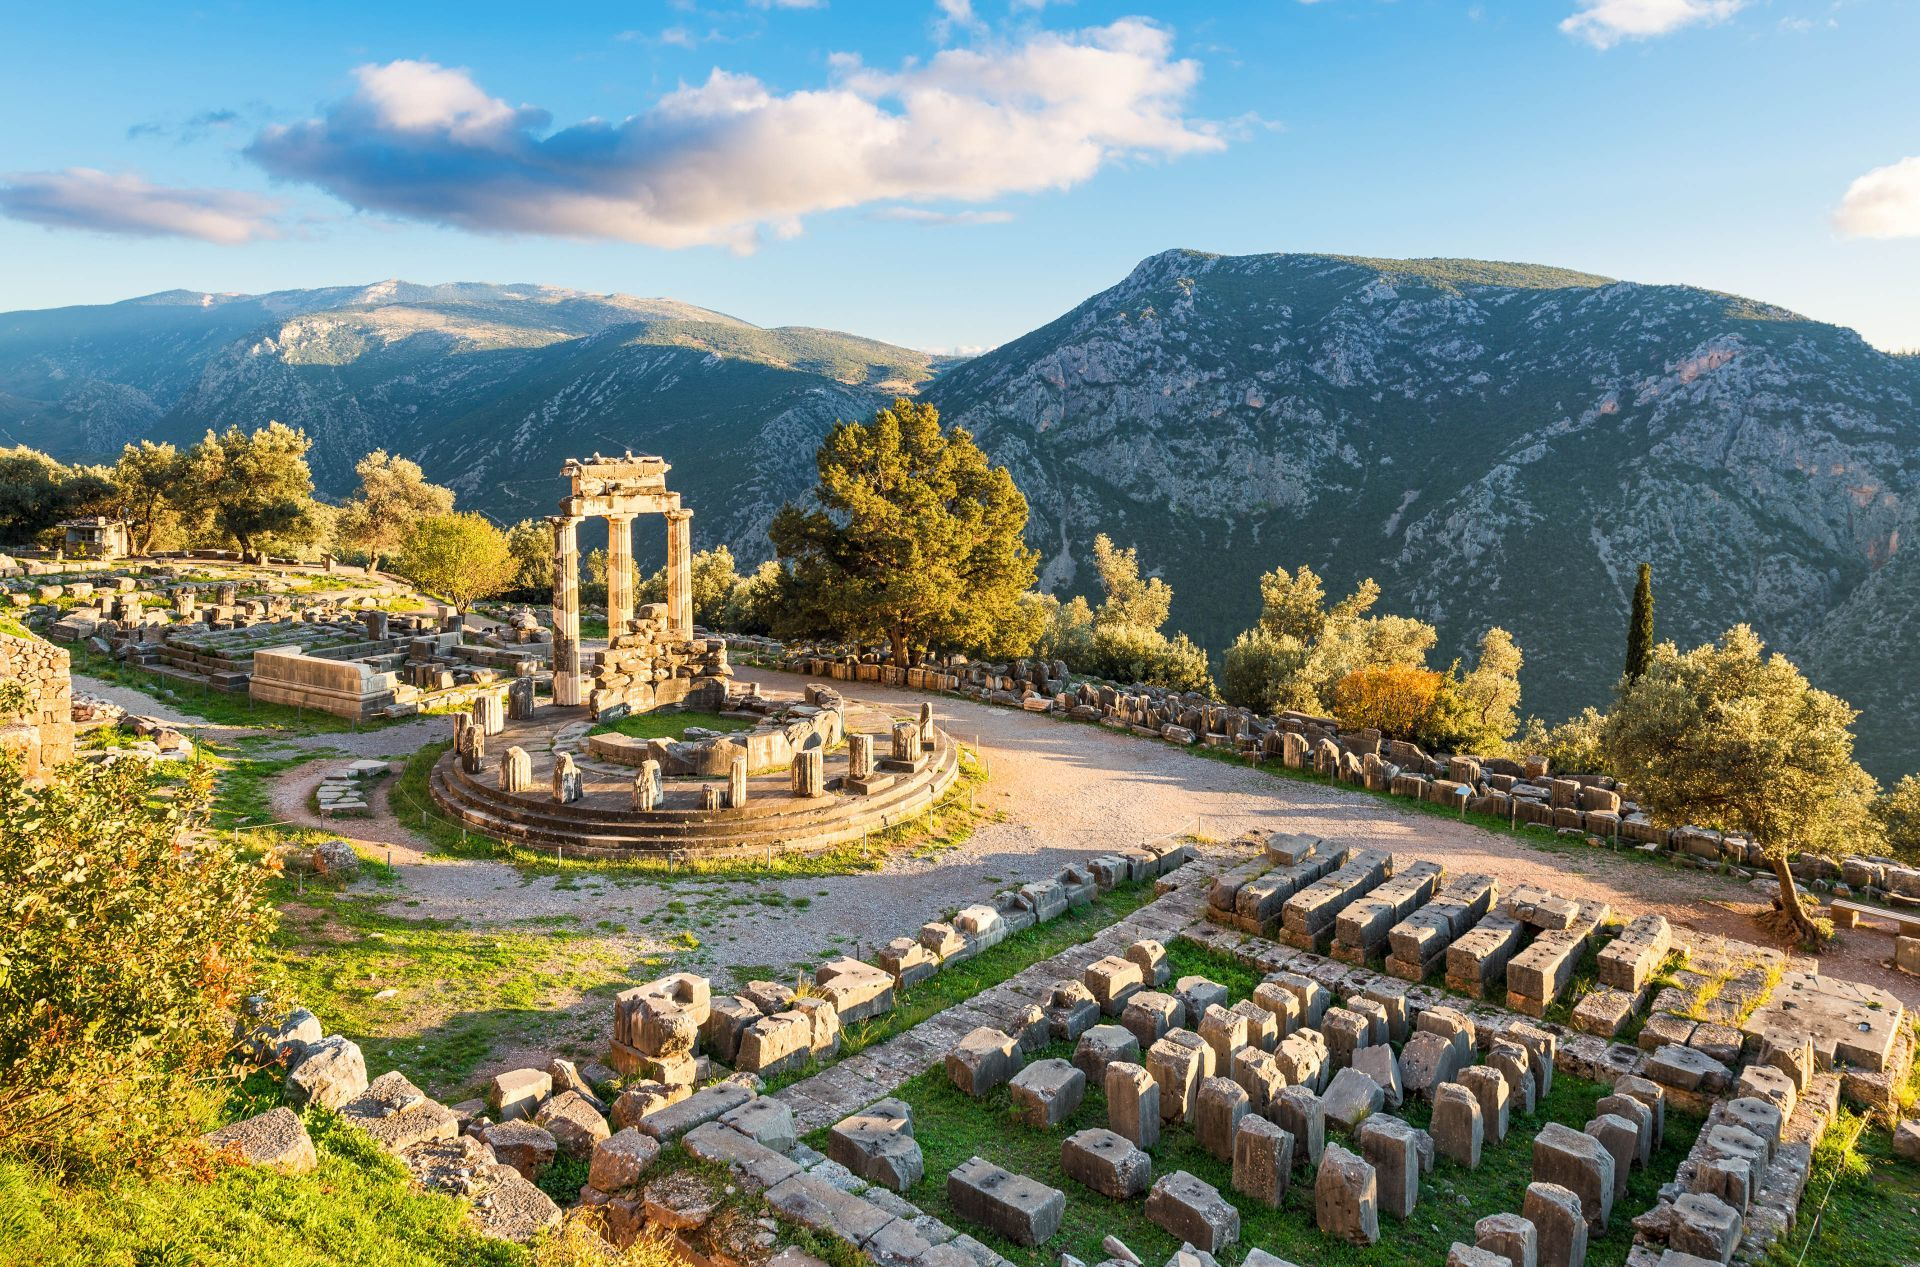Can you explain the significance of the circular building in the center of the photo? Certainly! The circular building is known as the Tholos. Located at the sanctuary of Athena Pronaia, it is an iconic structure at Delphi. Although its exact purpose remains a topic of debate among historians, it is believed to have been a place of worship or a treasury building. Its elegant circular construction with Doric columns showcases the sophisticated architectural style of ancient Greece and emphasizes its importance in the religious life of Delphi. 